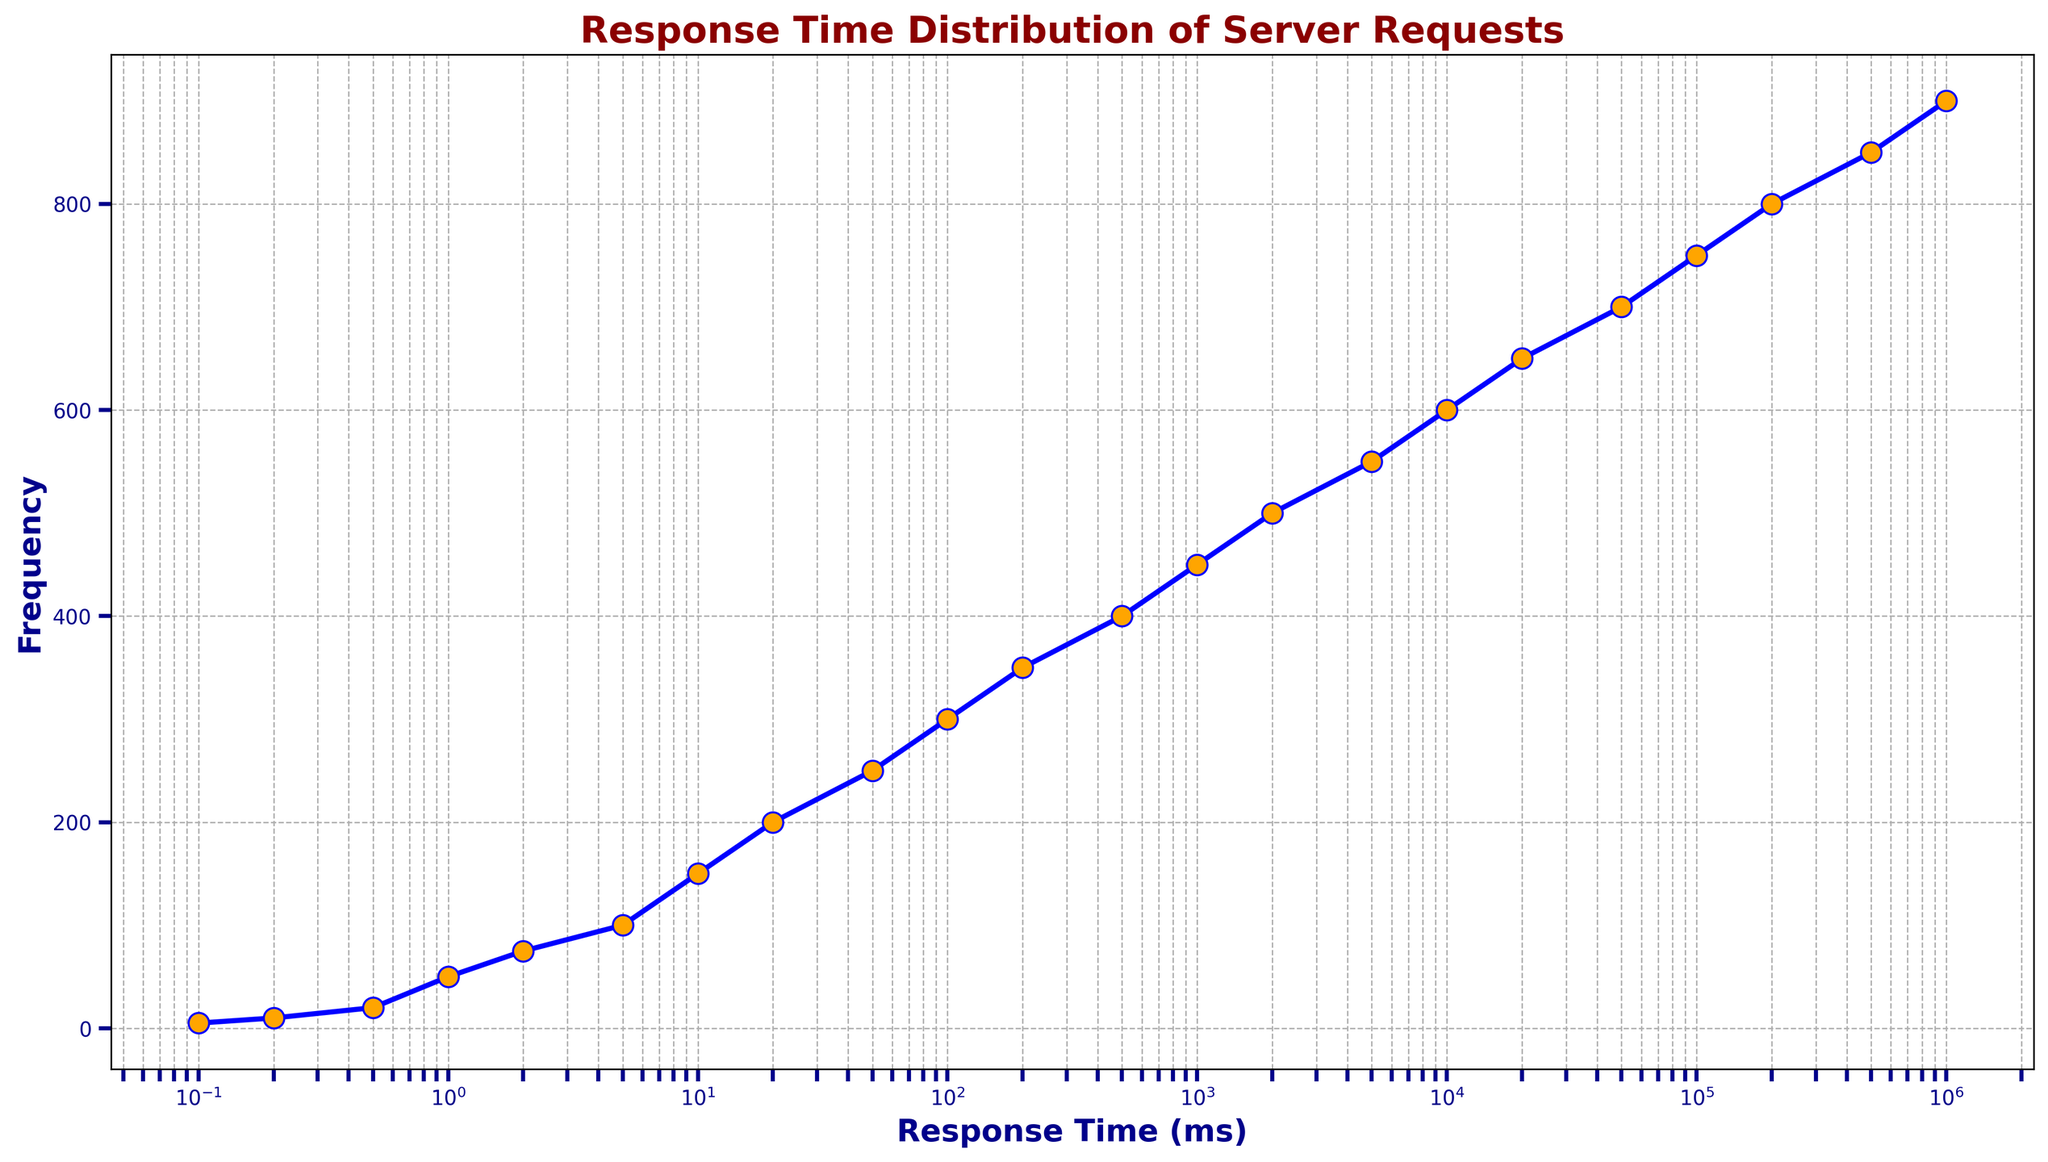What's the frequency of server requests with a response time of 200,000 ms? Identify the x-axis value at 200,000 ms and check the corresponding y-axis value. The figure shows 200,000 ms with a frequency of 800.
Answer: 800 Is the frequency of server requests at 2 ms greater than at 100,000 ms? Compare the y-axis values for response times of 2 ms and 100,000 ms. For 2 ms, the frequency is 75 and for 100,000 ms, it is 750. 750 is greater than 75.
Answer: No What is the difference in frequency between server requests with response times of 10 ms and 50 ms? Calculate the y-axis difference between 10 ms (frequency 150) and 50 ms (frequency 250). The difference is 250 - 150 = 100.
Answer: 100 Which response time has the highest frequency of requests? Identify the x-axis value that corresponds to the highest y-axis value of 900. The highest frequency occurs at 1,000,000 ms.
Answer: 1,000,000 ms What's the median response time if measured in an arithmetic scale assuming the given data points? Arrange response times: 0.1, 0.2, ..., 1,000,000 ms. The median is the middle number. Here, there are 23 data points, so the median is the 12th value. The 12th value is 500 ms.
Answer: 500 ms At which response time does the frequency first reach or exceed 500? Identify the first occurrence on the x-axis where the y-axis value is 500. This occurs at 2,000 ms.
Answer: 2,000 ms Is the increase in frequency between 2 ms and 20 ms larger than the increase between 50 ms and 200 ms? Compare differences in frequency: 2 ms to 20 ms (200-75=125), 50 ms to 200 ms (350-250=100). 125 is greater than 100.
Answer: Yes What is the average frequency for server requests with response times at 0.1 ms, 1 ms, 10 ms, 100 ms, and 1,000 ms? Find the frequencies: 0.1 ms (5), 1 ms (50), 10 ms (150), 100 ms (300), 1,000 ms (450). Average = (5+50+150+300+450)/5 = 955/5 = 191.
Answer: 191 Does the response time of 5,000 ms have a higher or lower frequency than the response time of 50,000 ms? Compare the y-axis values for 5,000 ms (frequency 550) and 50,000 ms (frequency 700). 700 is higher than 550.
Answer: Lower What is the rate of change in frequency between the response times 0.2 ms and 2 ms? Find frequencies at 0.2 ms (10) and 2 ms (75). The change is 75 - 10 = 65.
Answer: 65 